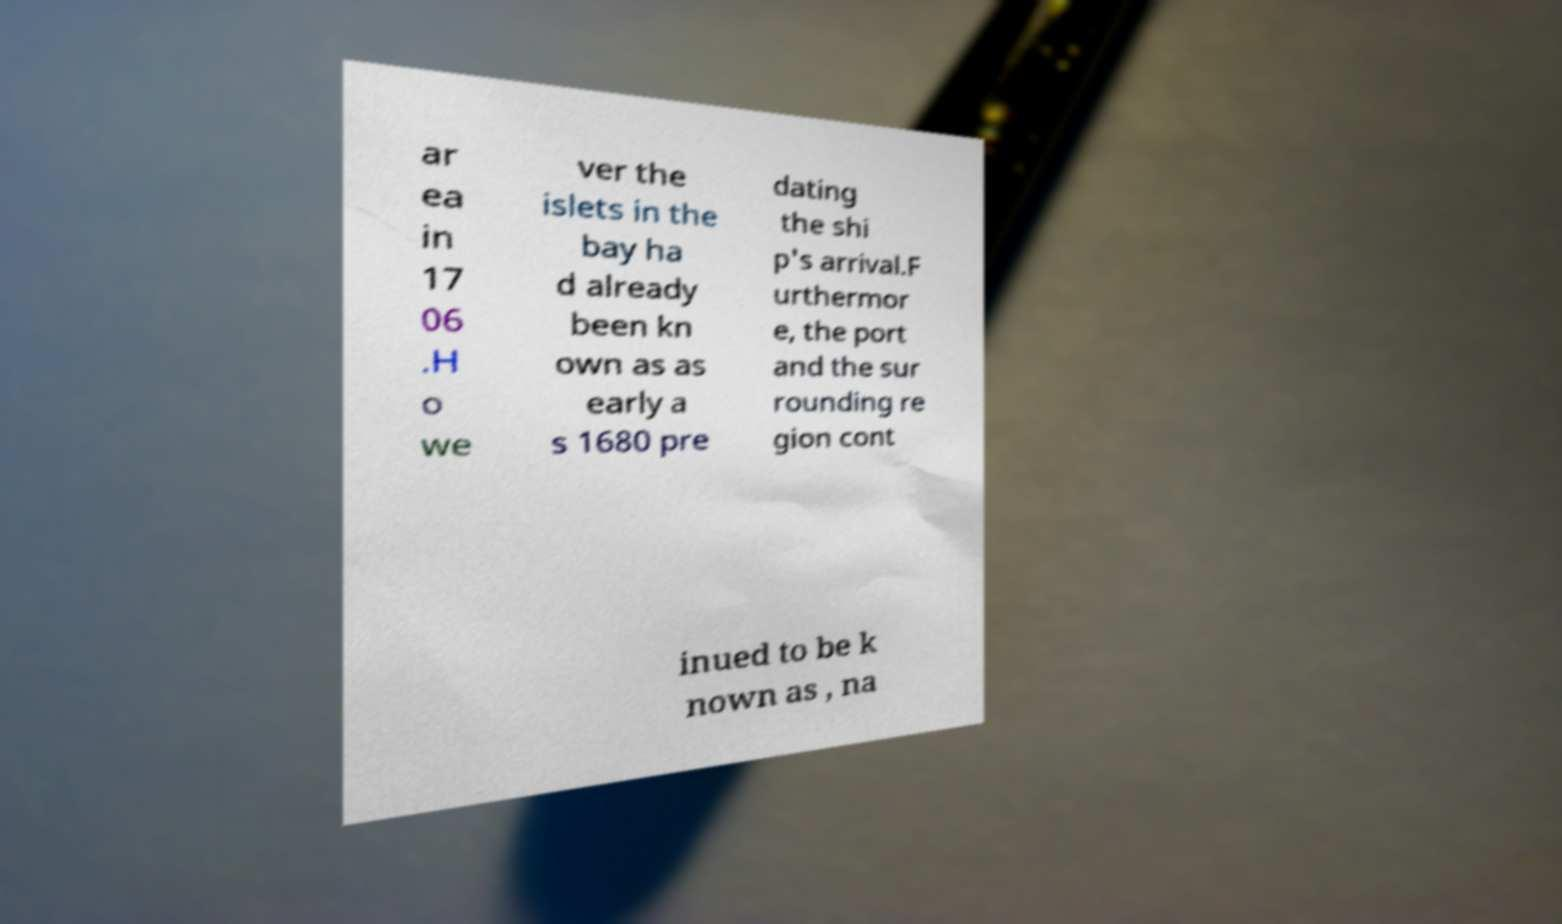Please identify and transcribe the text found in this image. ar ea in 17 06 .H o we ver the islets in the bay ha d already been kn own as as early a s 1680 pre dating the shi p's arrival.F urthermor e, the port and the sur rounding re gion cont inued to be k nown as , na 